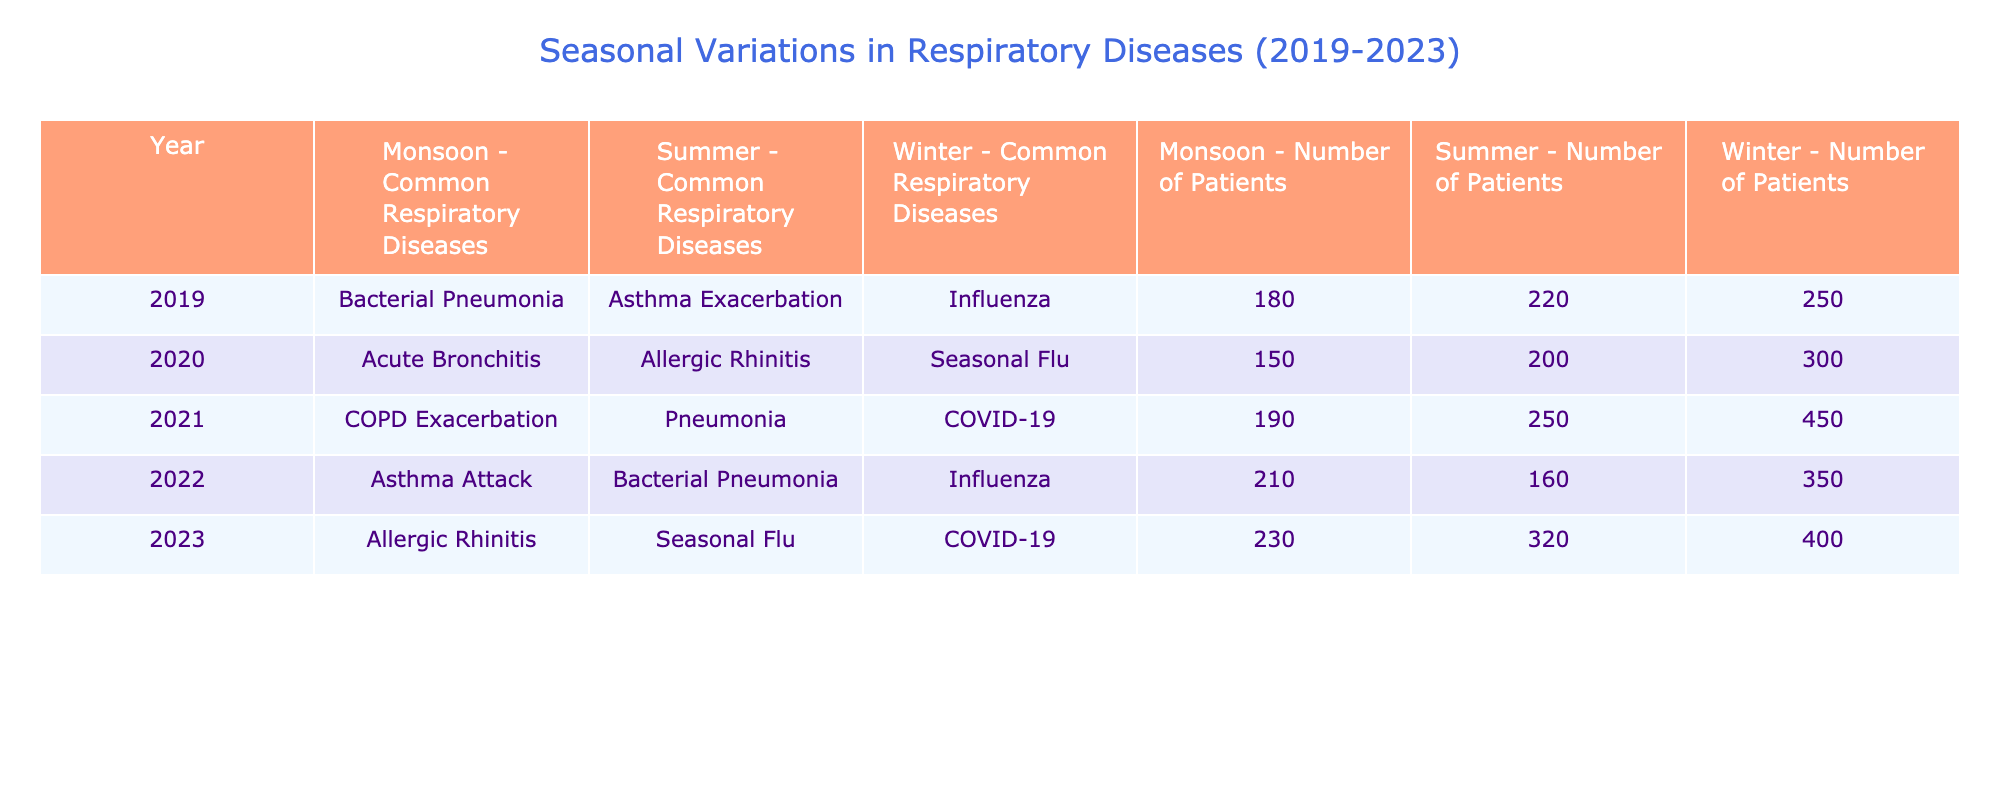What respiratory disease had the highest number of patients in the year 2021? In 2021, the table shows that the number of patients with COVID-19 was 450. No other disease listed for that year had more patients.
Answer: COVID-19 Which season had the least number of patients for respiratory diseases in 2020? The table shows that in 2020, Acute Bronchitis during the Monsoon had the least number of patients, totaling 150.
Answer: Monsoon What respiratory disease saw a decline in patient numbers from 2020 to 2021? In 2020, the number of patients for Pneumonia in summer was 250. In 2021, Pneumonia is not listed under summer, indicating a decline in cases for that specific period.
Answer: Pneumonia How many patients were admitted for asthma exacerbation between 2019 and 2023? The number of patients for asthma exacerbation is 220 in summer 2019 and 210 for asthma attack in monsoon 2022. Adding those gives 220 + 210 = 430.
Answer: 430 In which season of 2023 was there the highest number of patients and how many? The table indicates that in 2023, during summer, there were 320 patients for Seasonal Flu, which is the highest compared to other seasons in 2023.
Answer: Summer (320) Did the number of patients with Influenza increase from 2019 to 2022? In 2019, there were 250 patients with Influenza in winter, and in 2022, there were 350 patients, which confirms an increase in cases.
Answer: Yes What is the average number of patients for the common respiratory diseases in the monsoon season across all five years? Adding the number of patients in the monsoon season gives 180 (2019) + 150 (2020) + 190 (2021) + 210 (2022) + 230 (2023) = 1,060. Dividing by 5 (the number of years) gives an average of 1,060/5 = 212.
Answer: 212 How many more patients suffered from Seasonal Flu in 2023 compared to the number of patients suffering from it in 2020? For Seasonal Flu, there were 320 patients in 2023 and 300 patients in 2020. The difference is 320 - 300 = 20 more patients in 2023.
Answer: 20 Which disease had the highest number of patients in winter across the five years? Reviewing winter data, COVID-19 had the highest number of patients in 2021, at 450, making it the highest among all winters from 2019 to 2023.
Answer: COVID-19 (450) What was the total number of patients for bacterial pneumonia over the years? There were 180 patients in 2019, 160 in 2022, and no data for other years, leading to a total of 180 + 160 = 340 patients for bacterial pneumonia.
Answer: 340 